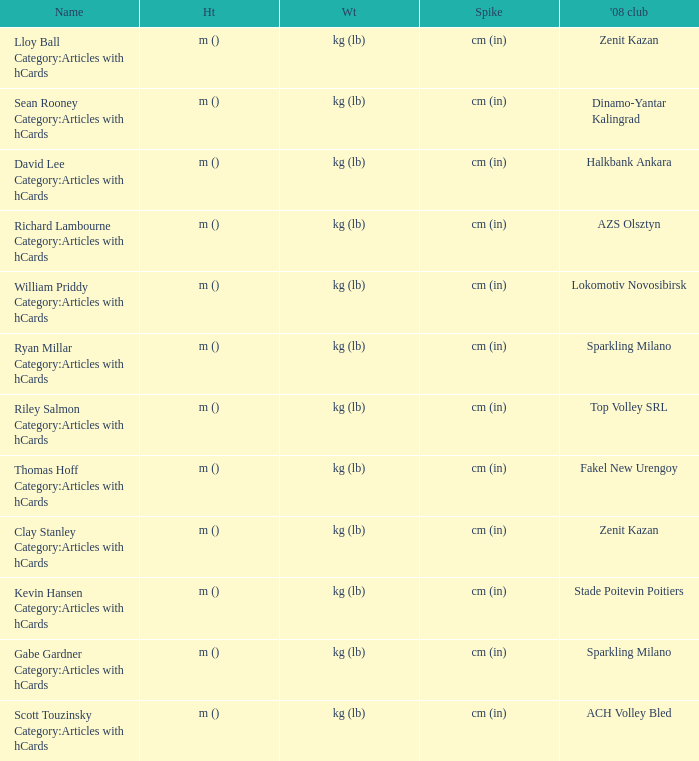What is the name for the 2008 club of Azs olsztyn? Richard Lambourne Category:Articles with hCards. 